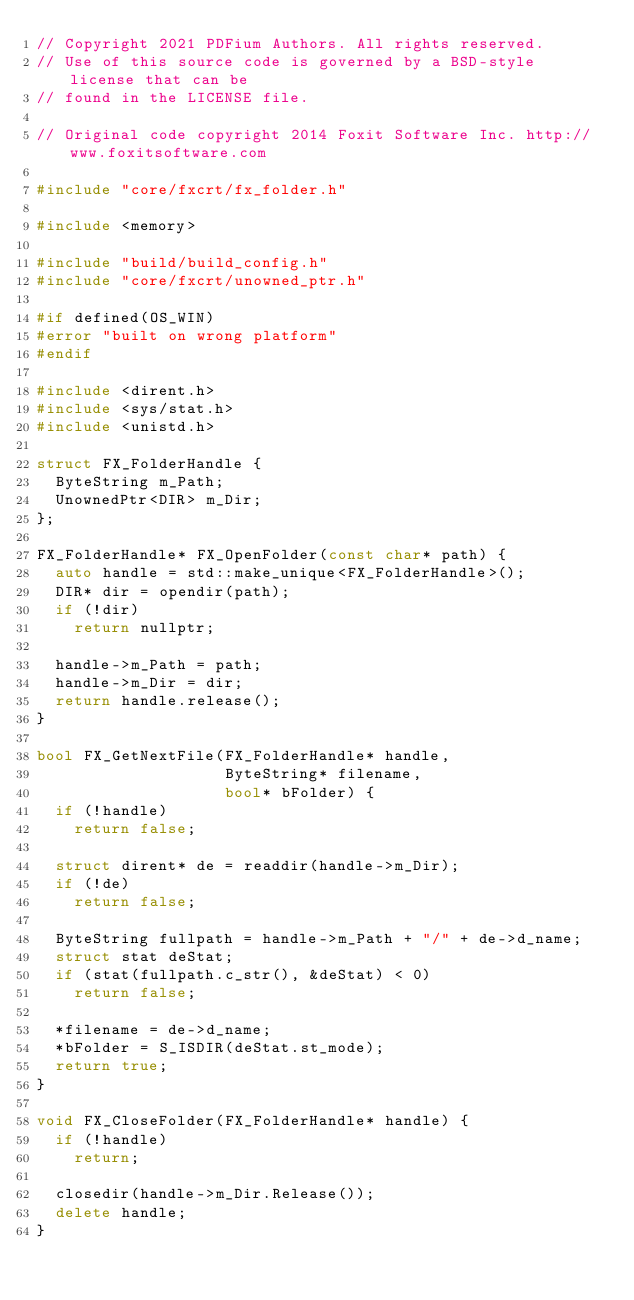<code> <loc_0><loc_0><loc_500><loc_500><_C++_>// Copyright 2021 PDFium Authors. All rights reserved.
// Use of this source code is governed by a BSD-style license that can be
// found in the LICENSE file.

// Original code copyright 2014 Foxit Software Inc. http://www.foxitsoftware.com

#include "core/fxcrt/fx_folder.h"

#include <memory>

#include "build/build_config.h"
#include "core/fxcrt/unowned_ptr.h"

#if defined(OS_WIN)
#error "built on wrong platform"
#endif

#include <dirent.h>
#include <sys/stat.h>
#include <unistd.h>

struct FX_FolderHandle {
  ByteString m_Path;
  UnownedPtr<DIR> m_Dir;
};

FX_FolderHandle* FX_OpenFolder(const char* path) {
  auto handle = std::make_unique<FX_FolderHandle>();
  DIR* dir = opendir(path);
  if (!dir)
    return nullptr;

  handle->m_Path = path;
  handle->m_Dir = dir;
  return handle.release();
}

bool FX_GetNextFile(FX_FolderHandle* handle,
                    ByteString* filename,
                    bool* bFolder) {
  if (!handle)
    return false;

  struct dirent* de = readdir(handle->m_Dir);
  if (!de)
    return false;

  ByteString fullpath = handle->m_Path + "/" + de->d_name;
  struct stat deStat;
  if (stat(fullpath.c_str(), &deStat) < 0)
    return false;

  *filename = de->d_name;
  *bFolder = S_ISDIR(deStat.st_mode);
  return true;
}

void FX_CloseFolder(FX_FolderHandle* handle) {
  if (!handle)
    return;

  closedir(handle->m_Dir.Release());
  delete handle;
}
</code> 